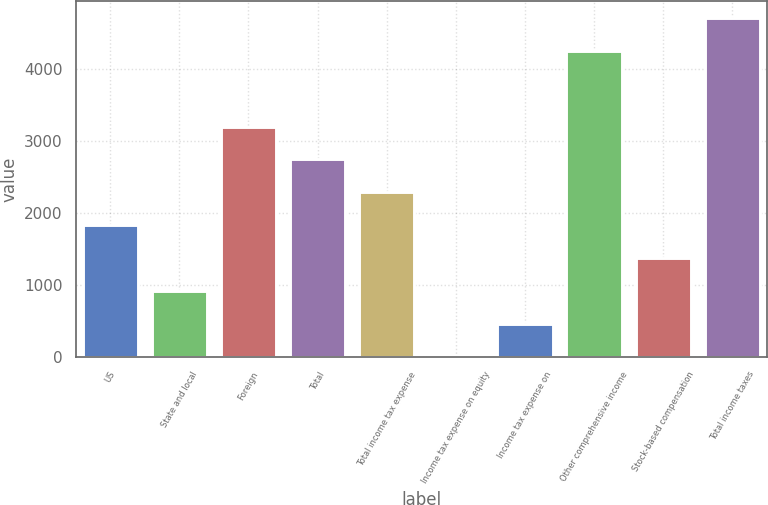Convert chart. <chart><loc_0><loc_0><loc_500><loc_500><bar_chart><fcel>US<fcel>State and local<fcel>Foreign<fcel>Total<fcel>Total income tax expense<fcel>Income tax expense on equity<fcel>Income tax expense on<fcel>Other comprehensive income<fcel>Stock-based compensation<fcel>Total income taxes<nl><fcel>1830.4<fcel>916.2<fcel>3201.7<fcel>2744.6<fcel>2287.5<fcel>2<fcel>459.1<fcel>4249<fcel>1373.3<fcel>4706.1<nl></chart> 